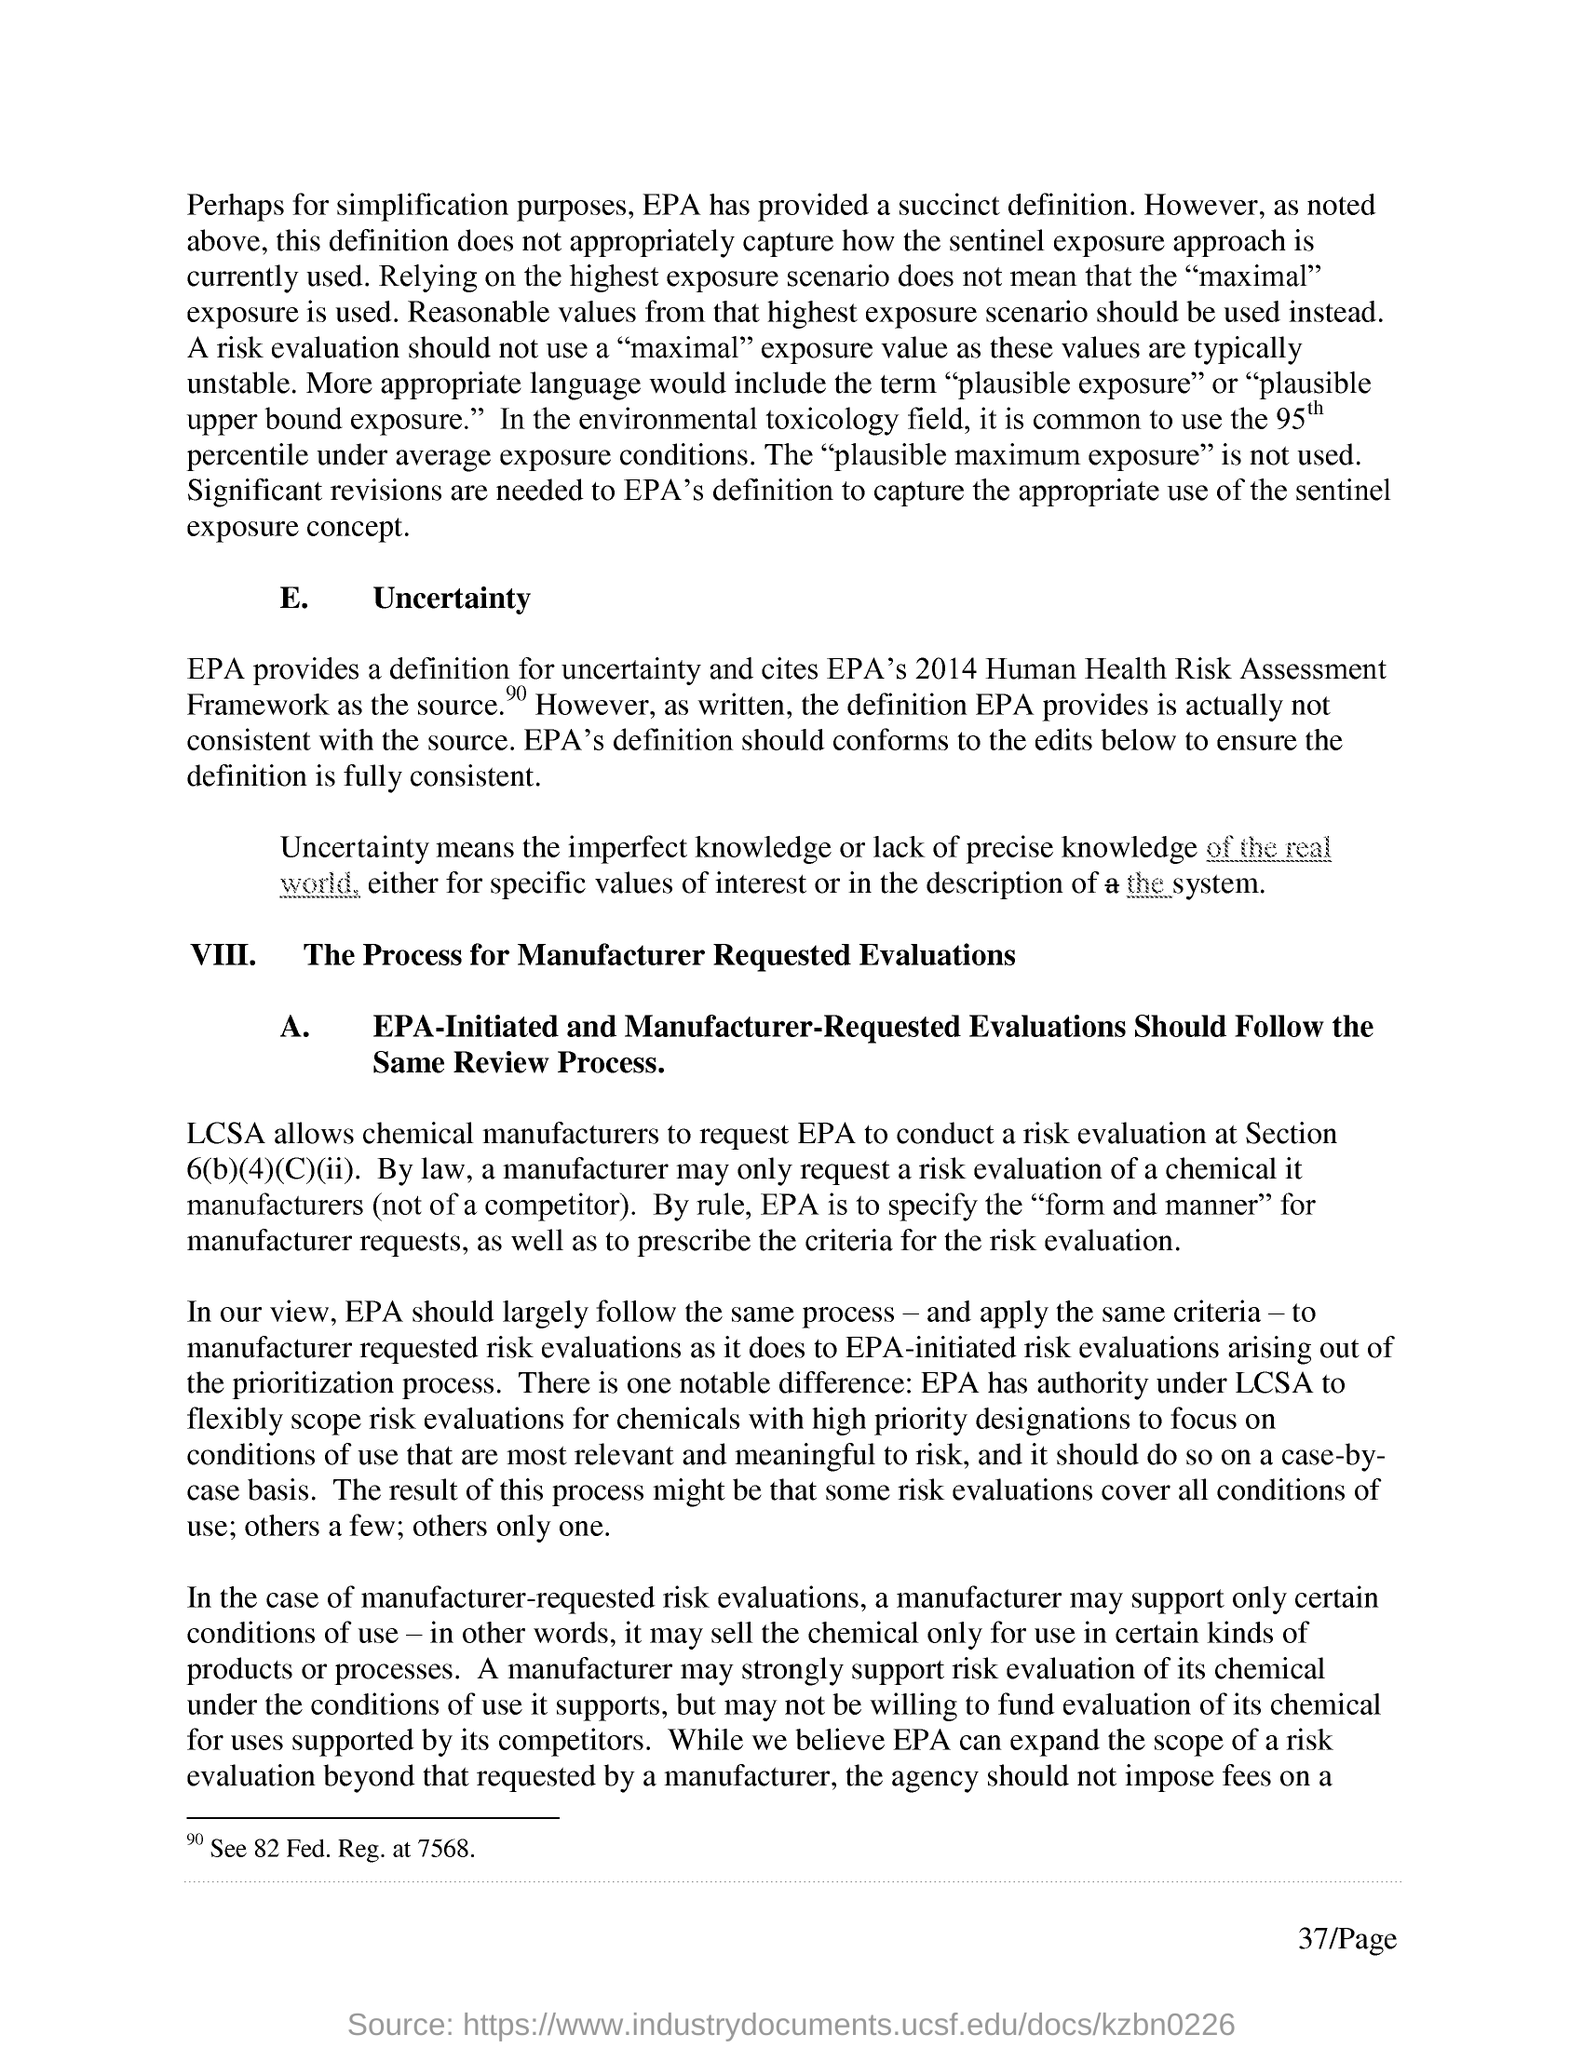List a handful of essential elements in this visual. The environmental toxicology field does not use the "plausible maximum exposure. The commonly used method in environmental toxicology is to determine the LC50, which is the concentration of a toxicant that is lethal to 50% of the test organisms under average exposure conditions. EPA cites its 2014 Human Health Risk Assessment Framework as the source for its information on the health effects of exposure to per- and polyfluoroalkyl substances (PFAS). 